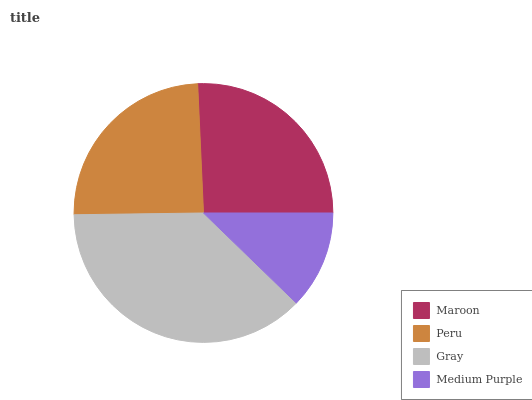Is Medium Purple the minimum?
Answer yes or no. Yes. Is Gray the maximum?
Answer yes or no. Yes. Is Peru the minimum?
Answer yes or no. No. Is Peru the maximum?
Answer yes or no. No. Is Maroon greater than Peru?
Answer yes or no. Yes. Is Peru less than Maroon?
Answer yes or no. Yes. Is Peru greater than Maroon?
Answer yes or no. No. Is Maroon less than Peru?
Answer yes or no. No. Is Maroon the high median?
Answer yes or no. Yes. Is Peru the low median?
Answer yes or no. Yes. Is Medium Purple the high median?
Answer yes or no. No. Is Medium Purple the low median?
Answer yes or no. No. 